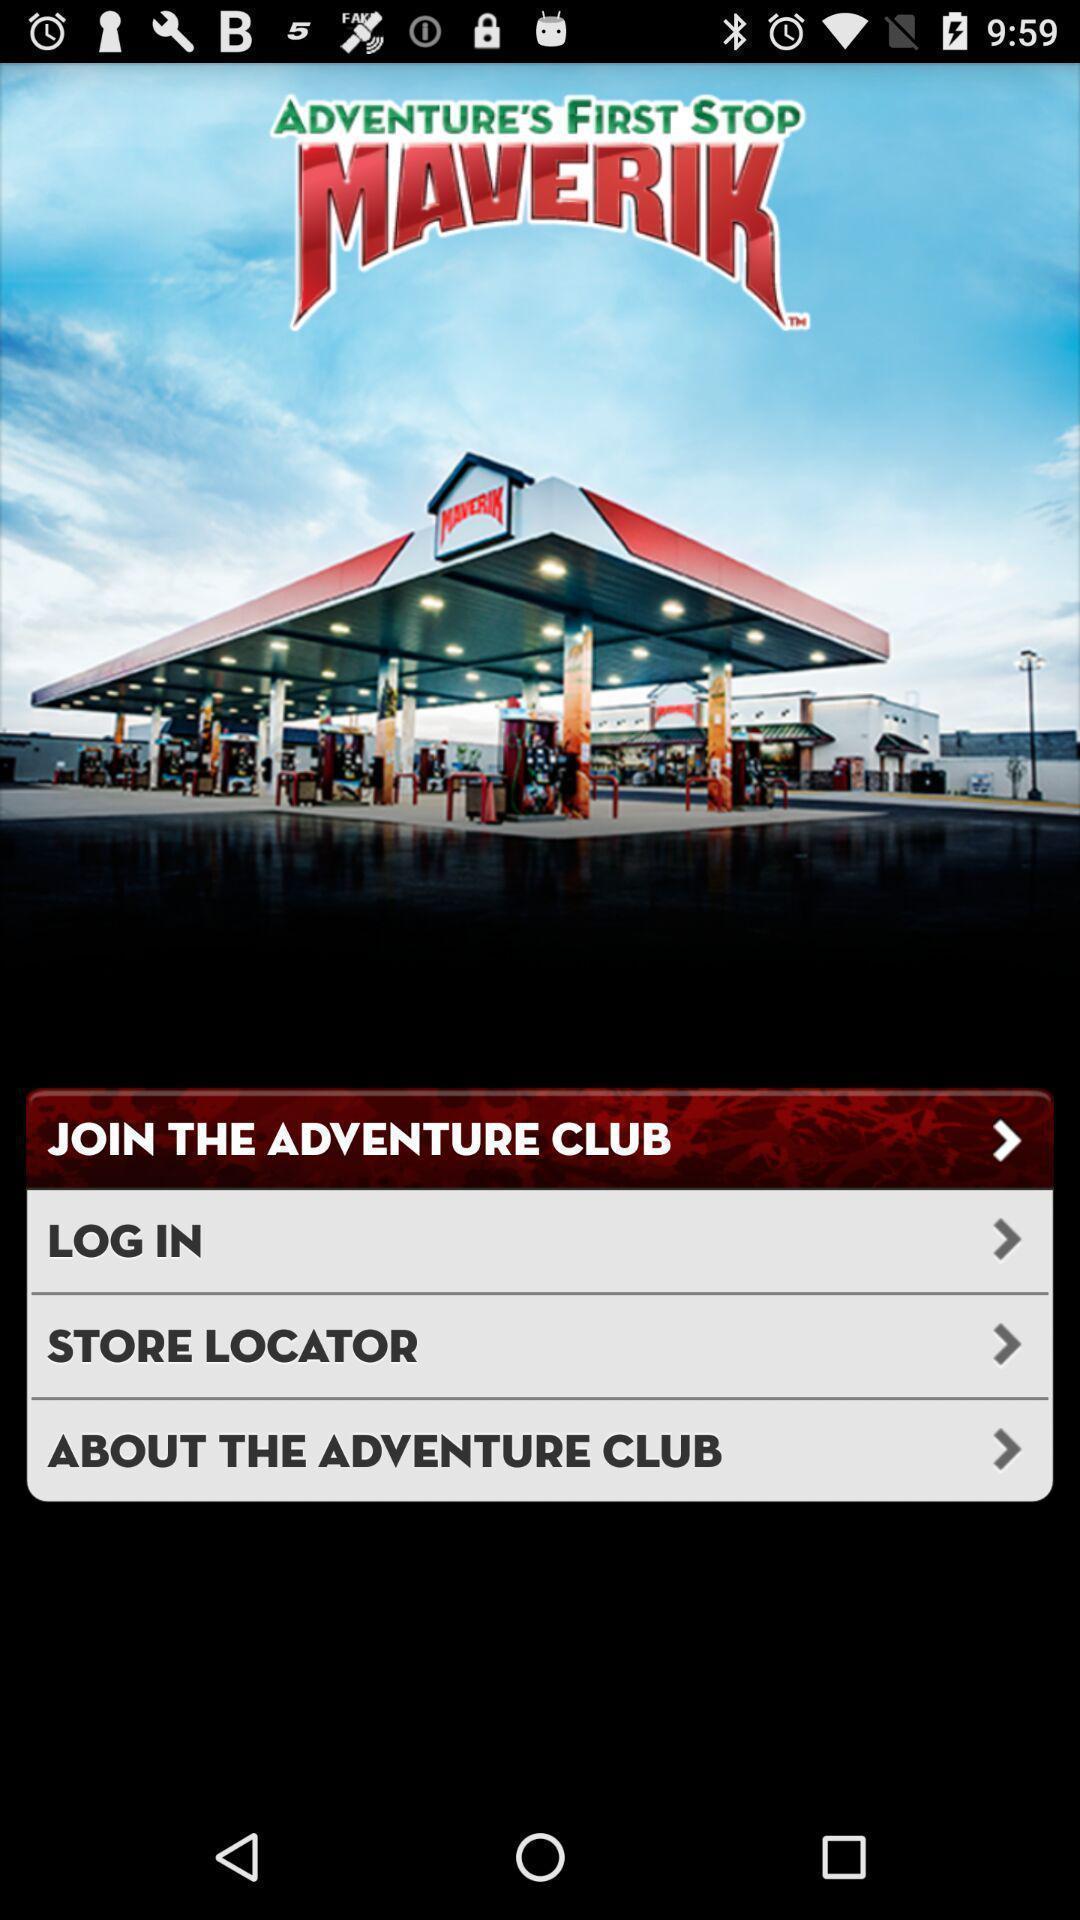Tell me about the visual elements in this screen capture. Starting page of the application with login option. 